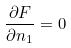<formula> <loc_0><loc_0><loc_500><loc_500>\frac { \partial F } { \partial n _ { 1 } } = 0</formula> 